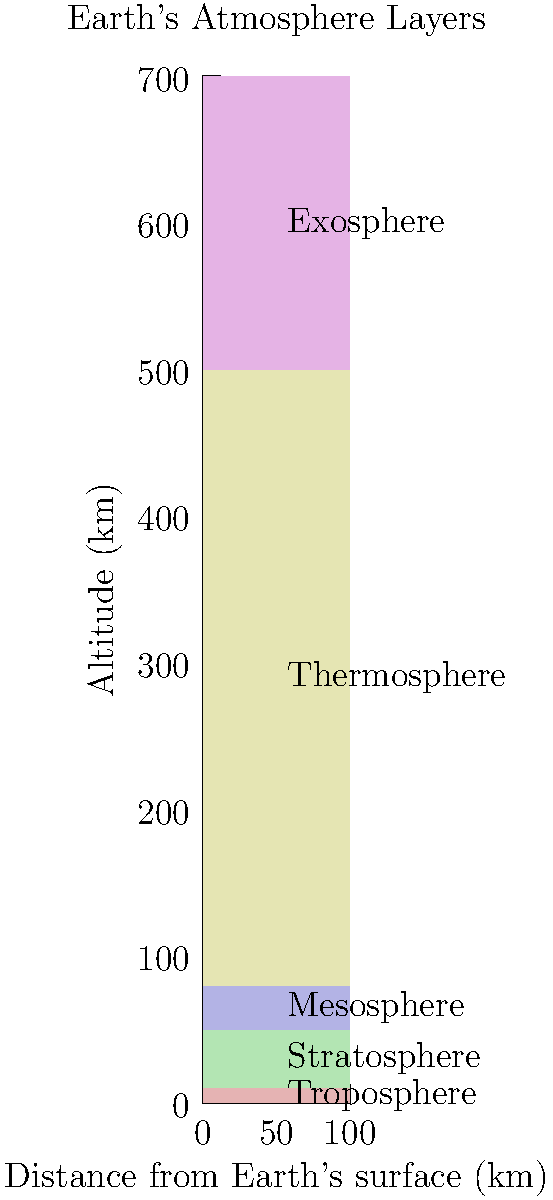In your latest science fiction novel review, you encounter a story where characters travel through Earth's atmosphere. Which layer of the atmosphere would they likely pass through last before entering space, and what unique characteristic does this layer possess that might intrigue sci-fi enthusiasts? To answer this question, let's examine the layers of Earth's atmosphere from the ground up:

1. Troposphere (0-10 km): The lowest layer where weather occurs.
2. Stratosphere (10-50 km): Contains the ozone layer.
3. Mesosphere (50-80 km): Where meteors often burn up.
4. Thermosphere (80-700 km): Aurora displays occur here.
5. Exosphere (700+ km): The outermost layer.

The characters would pass through these layers in order. The last layer they would encounter before entering space is the exosphere. 

What makes the exosphere unique and potentially intriguing for sci-fi enthusiasts:

1. It's the thinnest layer of the atmosphere, gradually fading into space.
2. It extends from about 700 km to 10,000 km above Earth's surface.
3. The particles in this layer are so sparse that they rarely collide.
4. Some consider it to be part of outer space due to its characteristics.
5. Satellites in low Earth orbit often pass through this layer.

The exosphere's unique properties, such as its near-vacuum state and gradual transition into space, could provide interesting plot elements or scientific challenges in a science fiction story.
Answer: Exosphere; it's the thinnest layer gradually fading into space. 